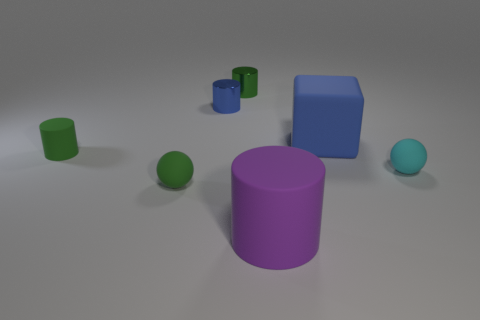Subtract all brown cylinders. Subtract all blue balls. How many cylinders are left? 4 Add 2 purple cylinders. How many objects exist? 9 Subtract all cylinders. How many objects are left? 3 Add 7 rubber blocks. How many rubber blocks are left? 8 Add 1 large rubber cylinders. How many large rubber cylinders exist? 2 Subtract 0 yellow balls. How many objects are left? 7 Subtract all tiny objects. Subtract all green spheres. How many objects are left? 1 